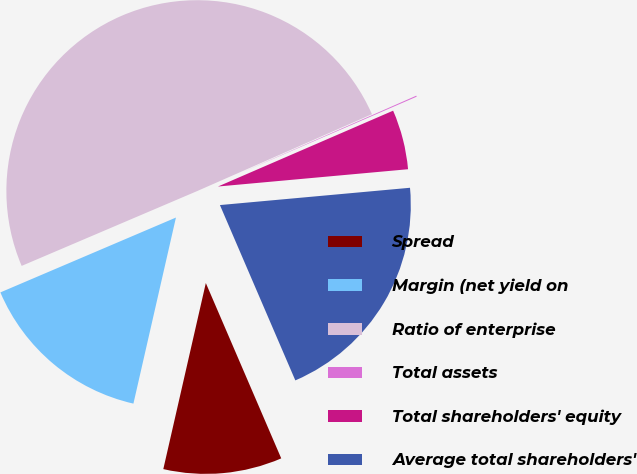<chart> <loc_0><loc_0><loc_500><loc_500><pie_chart><fcel>Spread<fcel>Margin (net yield on<fcel>Ratio of enterprise<fcel>Total assets<fcel>Total shareholders' equity<fcel>Average total shareholders'<nl><fcel>10.04%<fcel>15.01%<fcel>49.82%<fcel>0.09%<fcel>5.06%<fcel>19.98%<nl></chart> 